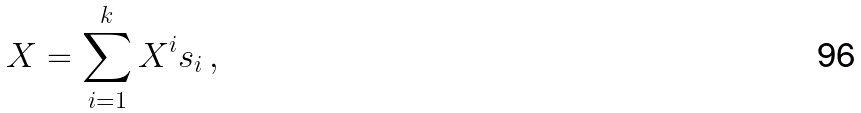<formula> <loc_0><loc_0><loc_500><loc_500>X = \sum _ { i = 1 } ^ { k } X ^ { i } s _ { i } \, ,</formula> 